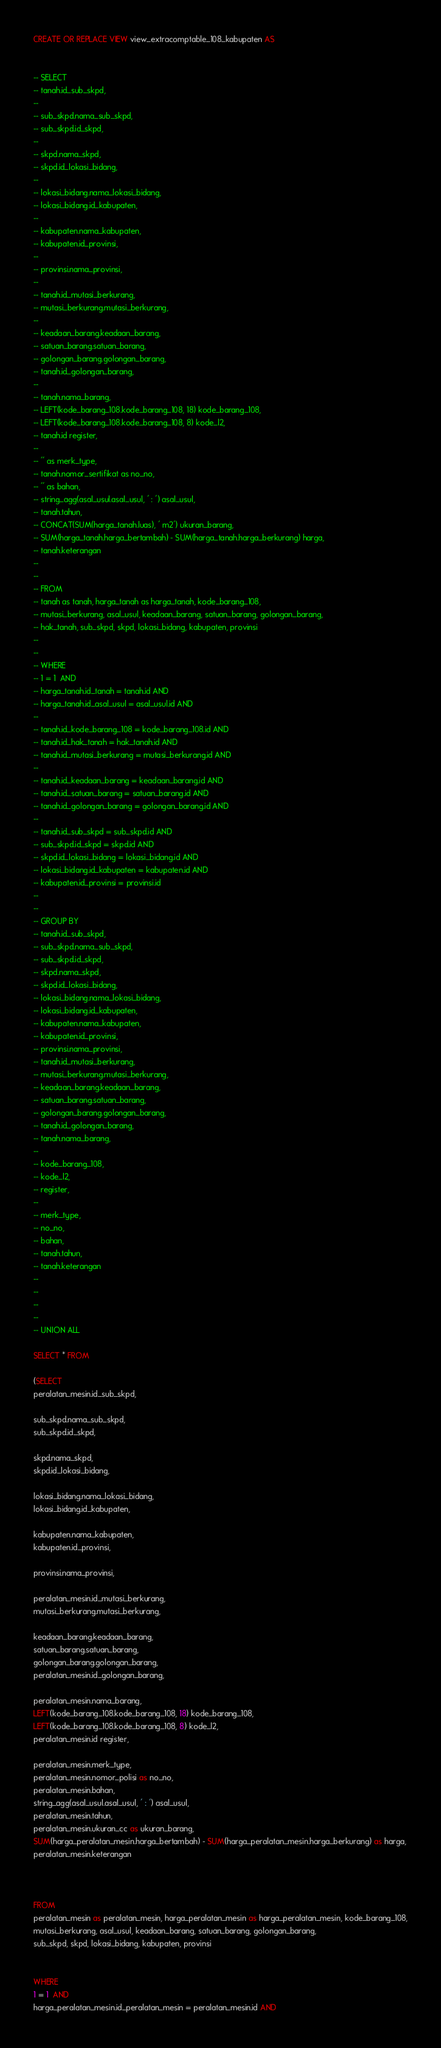Convert code to text. <code><loc_0><loc_0><loc_500><loc_500><_SQL_>CREATE OR REPLACE VIEW view_extracomptable_108_kabupaten AS


-- SELECT
-- tanah.id_sub_skpd,
--
-- sub_skpd.nama_sub_skpd,
-- sub_skpd.id_skpd,
--
-- skpd.nama_skpd,
-- skpd.id_lokasi_bidang,
--
-- lokasi_bidang.nama_lokasi_bidang,
-- lokasi_bidang.id_kabupaten,
--
-- kabupaten.nama_kabupaten,
-- kabupaten.id_provinsi,
--
-- provinsi.nama_provinsi,
--
-- tanah.id_mutasi_berkurang,
-- mutasi_berkurang.mutasi_berkurang,
--
-- keadaan_barang.keadaan_barang,
-- satuan_barang.satuan_barang,
-- golongan_barang.golongan_barang,
-- tanah.id_golongan_barang,
--
-- tanah.nama_barang,
-- LEFT(kode_barang_108.kode_barang_108, 18) kode_barang_108,
-- LEFT(kode_barang_108.kode_barang_108, 8) kode_l2,
-- tanah.id register,
--
-- '' as merk_type,
-- tanah.nomor_sertifikat as no_no,
-- '' as bahan,
-- string_agg(asal_usul.asal_usul, ' : ') asal_usul,
-- tanah.tahun,
-- CONCAT(SUM(harga_tanah.luas), ' m2') ukuran_barang,
-- SUM(harga_tanah.harga_bertambah) - SUM(harga_tanah.harga_berkurang) harga,
-- tanah.keterangan
--
--
-- FROM
-- tanah as tanah, harga_tanah as harga_tanah, kode_barang_108,
-- mutasi_berkurang, asal_usul, keadaan_barang, satuan_barang, golongan_barang,
-- hak_tanah, sub_skpd, skpd, lokasi_bidang, kabupaten, provinsi
--
--
-- WHERE
-- 1 = 1  AND
-- harga_tanah.id_tanah = tanah.id AND
-- harga_tanah.id_asal_usul = asal_usul.id AND
--
-- tanah.id_kode_barang_108 = kode_barang_108.id AND
-- tanah.id_hak_tanah = hak_tanah.id AND
-- tanah.id_mutasi_berkurang = mutasi_berkurang.id AND
--
-- tanah.id_keadaan_barang = keadaan_barang.id AND
-- tanah.id_satuan_barang = satuan_barang.id AND
-- tanah.id_golongan_barang = golongan_barang.id AND
--
-- tanah.id_sub_skpd = sub_skpd.id AND
-- sub_skpd.id_skpd = skpd.id AND
-- skpd.id_lokasi_bidang = lokasi_bidang.id AND
-- lokasi_bidang.id_kabupaten = kabupaten.id AND
-- kabupaten.id_provinsi = provinsi.id
--
--
-- GROUP BY
-- tanah.id_sub_skpd,
-- sub_skpd.nama_sub_skpd,
-- sub_skpd.id_skpd,
-- skpd.nama_skpd,
-- skpd.id_lokasi_bidang,
-- lokasi_bidang.nama_lokasi_bidang,
-- lokasi_bidang.id_kabupaten,
-- kabupaten.nama_kabupaten,
-- kabupaten.id_provinsi,
-- provinsi.nama_provinsi,
-- tanah.id_mutasi_berkurang,
-- mutasi_berkurang.mutasi_berkurang,
-- keadaan_barang.keadaan_barang,
-- satuan_barang.satuan_barang,
-- golongan_barang.golongan_barang,
-- tanah.id_golongan_barang,
-- tanah.nama_barang,
--
-- kode_barang_108,
-- kode_l2,
-- register,
--
-- merk_type,
-- no_no,
-- bahan,
-- tanah.tahun,
-- tanah.keterangan
--
--
--
--
-- UNION ALL

SELECT * FROM

(SELECT
peralatan_mesin.id_sub_skpd,

sub_skpd.nama_sub_skpd,
sub_skpd.id_skpd,

skpd.nama_skpd,
skpd.id_lokasi_bidang,

lokasi_bidang.nama_lokasi_bidang,
lokasi_bidang.id_kabupaten,

kabupaten.nama_kabupaten,
kabupaten.id_provinsi,

provinsi.nama_provinsi,

peralatan_mesin.id_mutasi_berkurang,
mutasi_berkurang.mutasi_berkurang,

keadaan_barang.keadaan_barang,
satuan_barang.satuan_barang,
golongan_barang.golongan_barang,
peralatan_mesin.id_golongan_barang,

peralatan_mesin.nama_barang,
LEFT(kode_barang_108.kode_barang_108, 18) kode_barang_108,
LEFT(kode_barang_108.kode_barang_108, 8) kode_l2,
peralatan_mesin.id register,

peralatan_mesin.merk_type,
peralatan_mesin.nomor_polisi as no_no,
peralatan_mesin.bahan,
string_agg(asal_usul.asal_usul, ' : ') asal_usul,
peralatan_mesin.tahun,
peralatan_mesin.ukuran_cc as ukuran_barang,
SUM(harga_peralatan_mesin.harga_bertambah) - SUM(harga_peralatan_mesin.harga_berkurang) as harga,
peralatan_mesin.keterangan



FROM
peralatan_mesin as peralatan_mesin, harga_peralatan_mesin as harga_peralatan_mesin, kode_barang_108,
mutasi_berkurang, asal_usul, keadaan_barang, satuan_barang, golongan_barang,
sub_skpd, skpd, lokasi_bidang, kabupaten, provinsi


WHERE
1 = 1  AND
harga_peralatan_mesin.id_peralatan_mesin = peralatan_mesin.id AND</code> 